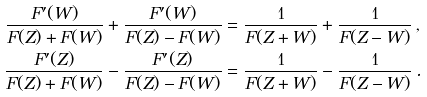Convert formula to latex. <formula><loc_0><loc_0><loc_500><loc_500>\frac { F ^ { \prime } ( W ) } { F ( Z ) + F ( W ) } + \frac { F ^ { \prime } ( W ) } { F ( Z ) - F ( W ) } & = \frac { 1 } { F ( Z + W ) } + \frac { 1 } { F ( Z - W ) } \, , \\ \frac { F ^ { \prime } ( Z ) } { F ( Z ) + F ( W ) } - \frac { F ^ { \prime } ( Z ) } { F ( Z ) - F ( W ) } & = \frac { 1 } { F ( Z + W ) } - \frac { 1 } { F ( Z - W ) } \, .</formula> 